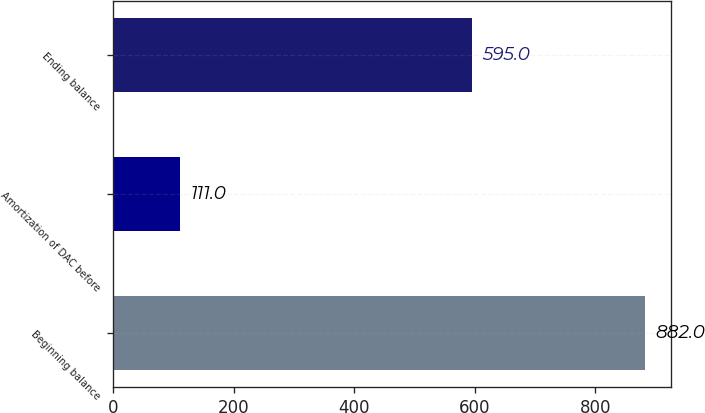<chart> <loc_0><loc_0><loc_500><loc_500><bar_chart><fcel>Beginning balance<fcel>Amortization of DAC before<fcel>Ending balance<nl><fcel>882<fcel>111<fcel>595<nl></chart> 